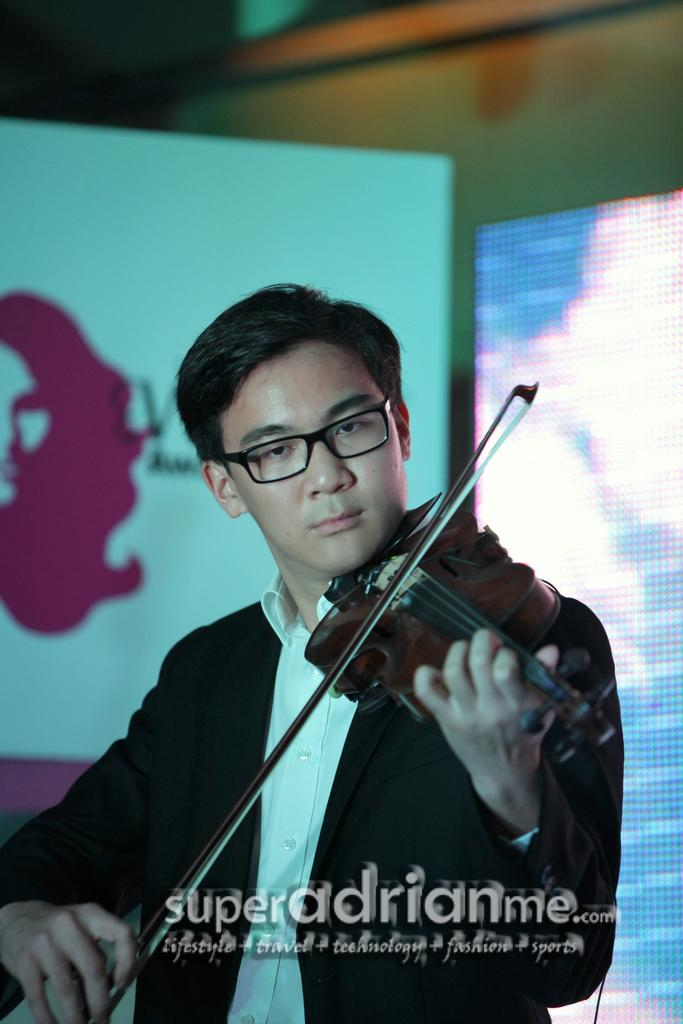What is the person in the image doing? The person is playing a violin. What is the person wearing in the image? The person is wearing a black suit and a white shirt. What can be seen in the background of the image? There is a board visible in the background of the image. What is the price of the violin in the image? The price of the violin is not visible in the image, so it cannot be determined. 